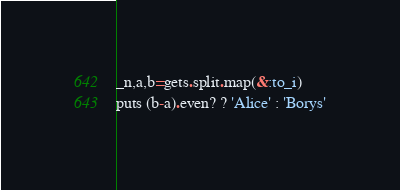<code> <loc_0><loc_0><loc_500><loc_500><_Ruby_>_n,a,b=gets.split.map(&:to_i)
puts (b-a).even? ? 'Alice' : 'Borys'</code> 